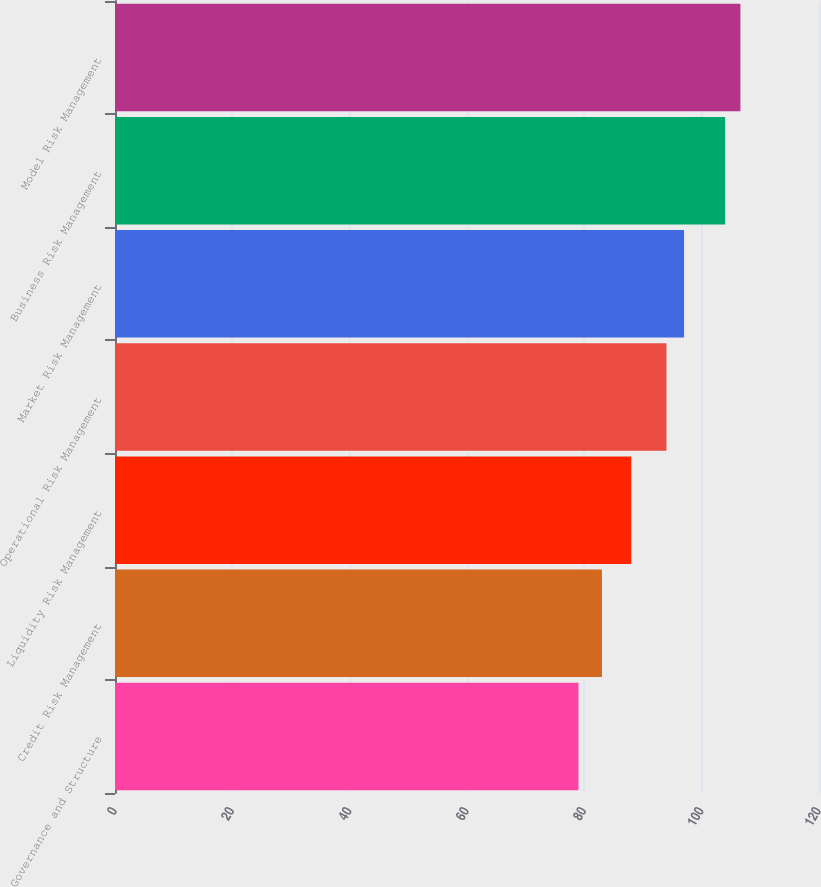Convert chart. <chart><loc_0><loc_0><loc_500><loc_500><bar_chart><fcel>Governance and Structure<fcel>Credit Risk Management<fcel>Liquidity Risk Management<fcel>Operational Risk Management<fcel>Market Risk Management<fcel>Business Risk Management<fcel>Model Risk Management<nl><fcel>79<fcel>83<fcel>88<fcel>94<fcel>97<fcel>104<fcel>106.6<nl></chart> 